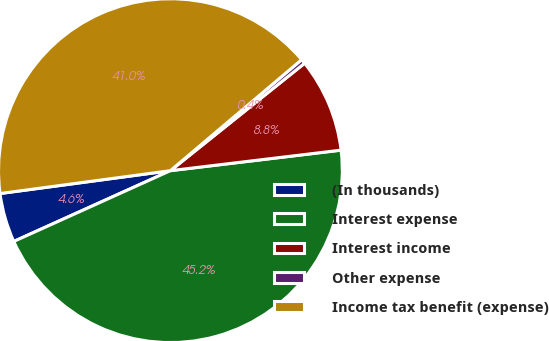Convert chart to OTSL. <chart><loc_0><loc_0><loc_500><loc_500><pie_chart><fcel>(In thousands)<fcel>Interest expense<fcel>Interest income<fcel>Other expense<fcel>Income tax benefit (expense)<nl><fcel>4.63%<fcel>45.15%<fcel>8.84%<fcel>0.43%<fcel>40.95%<nl></chart> 